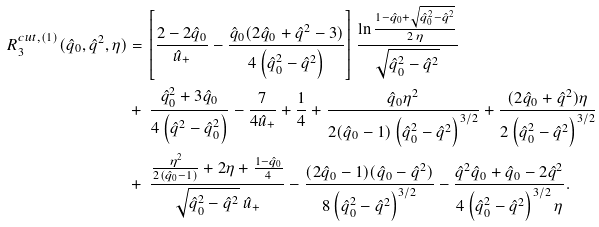<formula> <loc_0><loc_0><loc_500><loc_500>R _ { 3 } ^ { c u t , ( 1 ) } ( \hat { q } _ { 0 } , \hat { q } ^ { 2 } , \eta ) & = \left [ \frac { 2 - 2 \hat { q } _ { 0 } } { \hat { u } _ { + } } - \frac { \hat { q } _ { 0 } ( 2 \hat { q } _ { 0 } + \hat { q } ^ { 2 } - 3 ) } { 4 \left ( \hat { q } _ { 0 } ^ { 2 } - \hat { q } ^ { 2 } \right ) } \right ] \frac { \ln \frac { 1 - \hat { q } _ { 0 } + \sqrt { \hat { q } _ { 0 } ^ { 2 } - \hat { q } ^ { 2 } } } { 2 \, \eta } } { \sqrt { \hat { q } _ { 0 } ^ { 2 } - \hat { q } ^ { 2 } } } \\ & + \ \frac { \hat { q } _ { 0 } ^ { 2 } + 3 \hat { q } _ { 0 } } { 4 \left ( \hat { q } ^ { 2 } - \hat { q } _ { 0 } ^ { 2 } \right ) } - \frac { 7 } { 4 \hat { u } _ { + } } + \frac { 1 } { 4 } + \frac { \hat { q } _ { 0 } \eta ^ { 2 } } { 2 ( \hat { q } _ { 0 } - 1 ) \left ( \hat { q } _ { 0 } ^ { 2 } - \hat { q } ^ { 2 } \right ) ^ { 3 / 2 } } + \frac { ( 2 \hat { q } _ { 0 } + \hat { q } ^ { 2 } ) \eta } { 2 \left ( \hat { q } _ { 0 } ^ { 2 } - \hat { q } ^ { 2 } \right ) ^ { 3 / 2 } } \\ & + \ \frac { \frac { \eta ^ { 2 } } { 2 ( \hat { q } _ { 0 } - 1 ) } + 2 \eta + \frac { 1 - \hat { q } _ { 0 } } { 4 } } { \sqrt { \hat { q } _ { 0 } ^ { 2 } - \hat { q } ^ { 2 } } \ \hat { u } _ { + } } - \frac { ( 2 \hat { q } _ { 0 } - 1 ) ( \hat { q } _ { 0 } - \hat { q } ^ { 2 } ) } { 8 \left ( \hat { q } _ { 0 } ^ { 2 } - \hat { q } ^ { 2 } \right ) ^ { 3 / 2 } } - \frac { \hat { q } ^ { 2 } \hat { q } _ { 0 } + \hat { q } _ { 0 } - 2 \hat { q } ^ { 2 } } { 4 \left ( \hat { q } _ { 0 } ^ { 2 } - \hat { q } ^ { 2 } \right ) ^ { 3 / 2 } \eta } .</formula> 